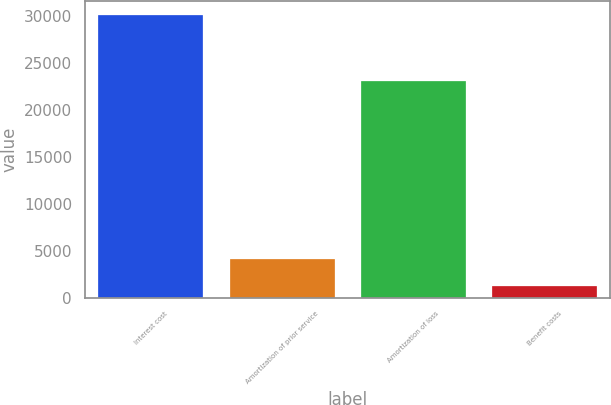<chart> <loc_0><loc_0><loc_500><loc_500><bar_chart><fcel>Interest cost<fcel>Amortization of prior service<fcel>Amortization of loss<fcel>Benefit costs<nl><fcel>30112<fcel>4075<fcel>23044<fcel>1182<nl></chart> 